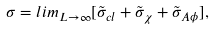<formula> <loc_0><loc_0><loc_500><loc_500>\sigma = l i m _ { L \rightarrow \infty } [ \tilde { \sigma } _ { c l } + \tilde { \sigma } _ { \chi } + \tilde { \sigma } _ { A \phi } ] ,</formula> 